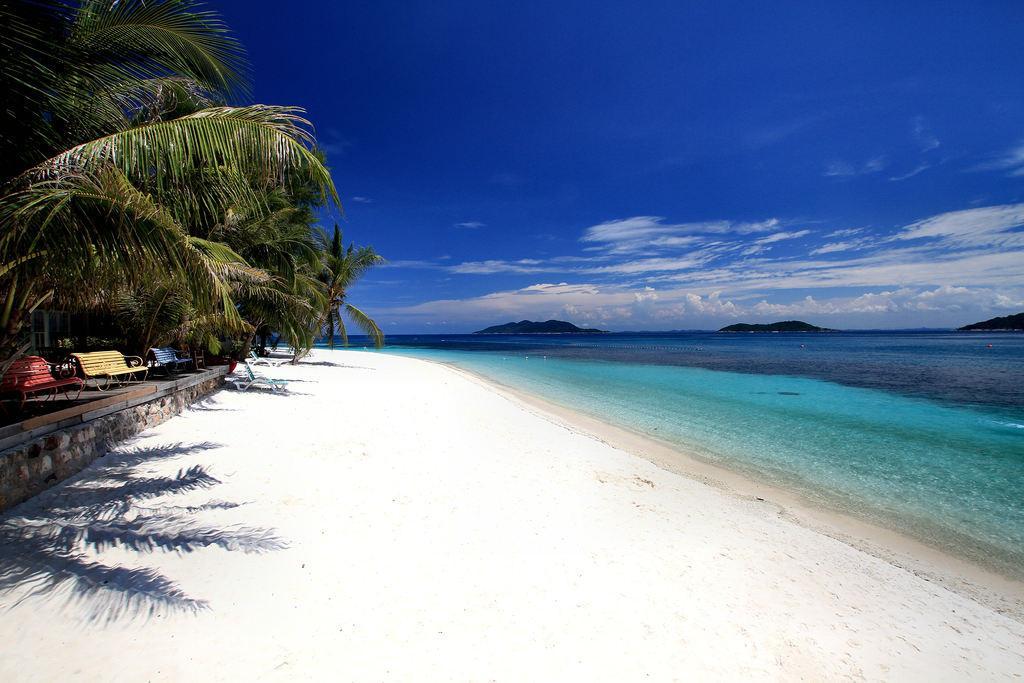Could you give a brief overview of what you see in this image? This is a picture of a seashore, at the left side there are some green trees and we can see some benches, there is a sea and we can see water, at the top there is a blue sky. 